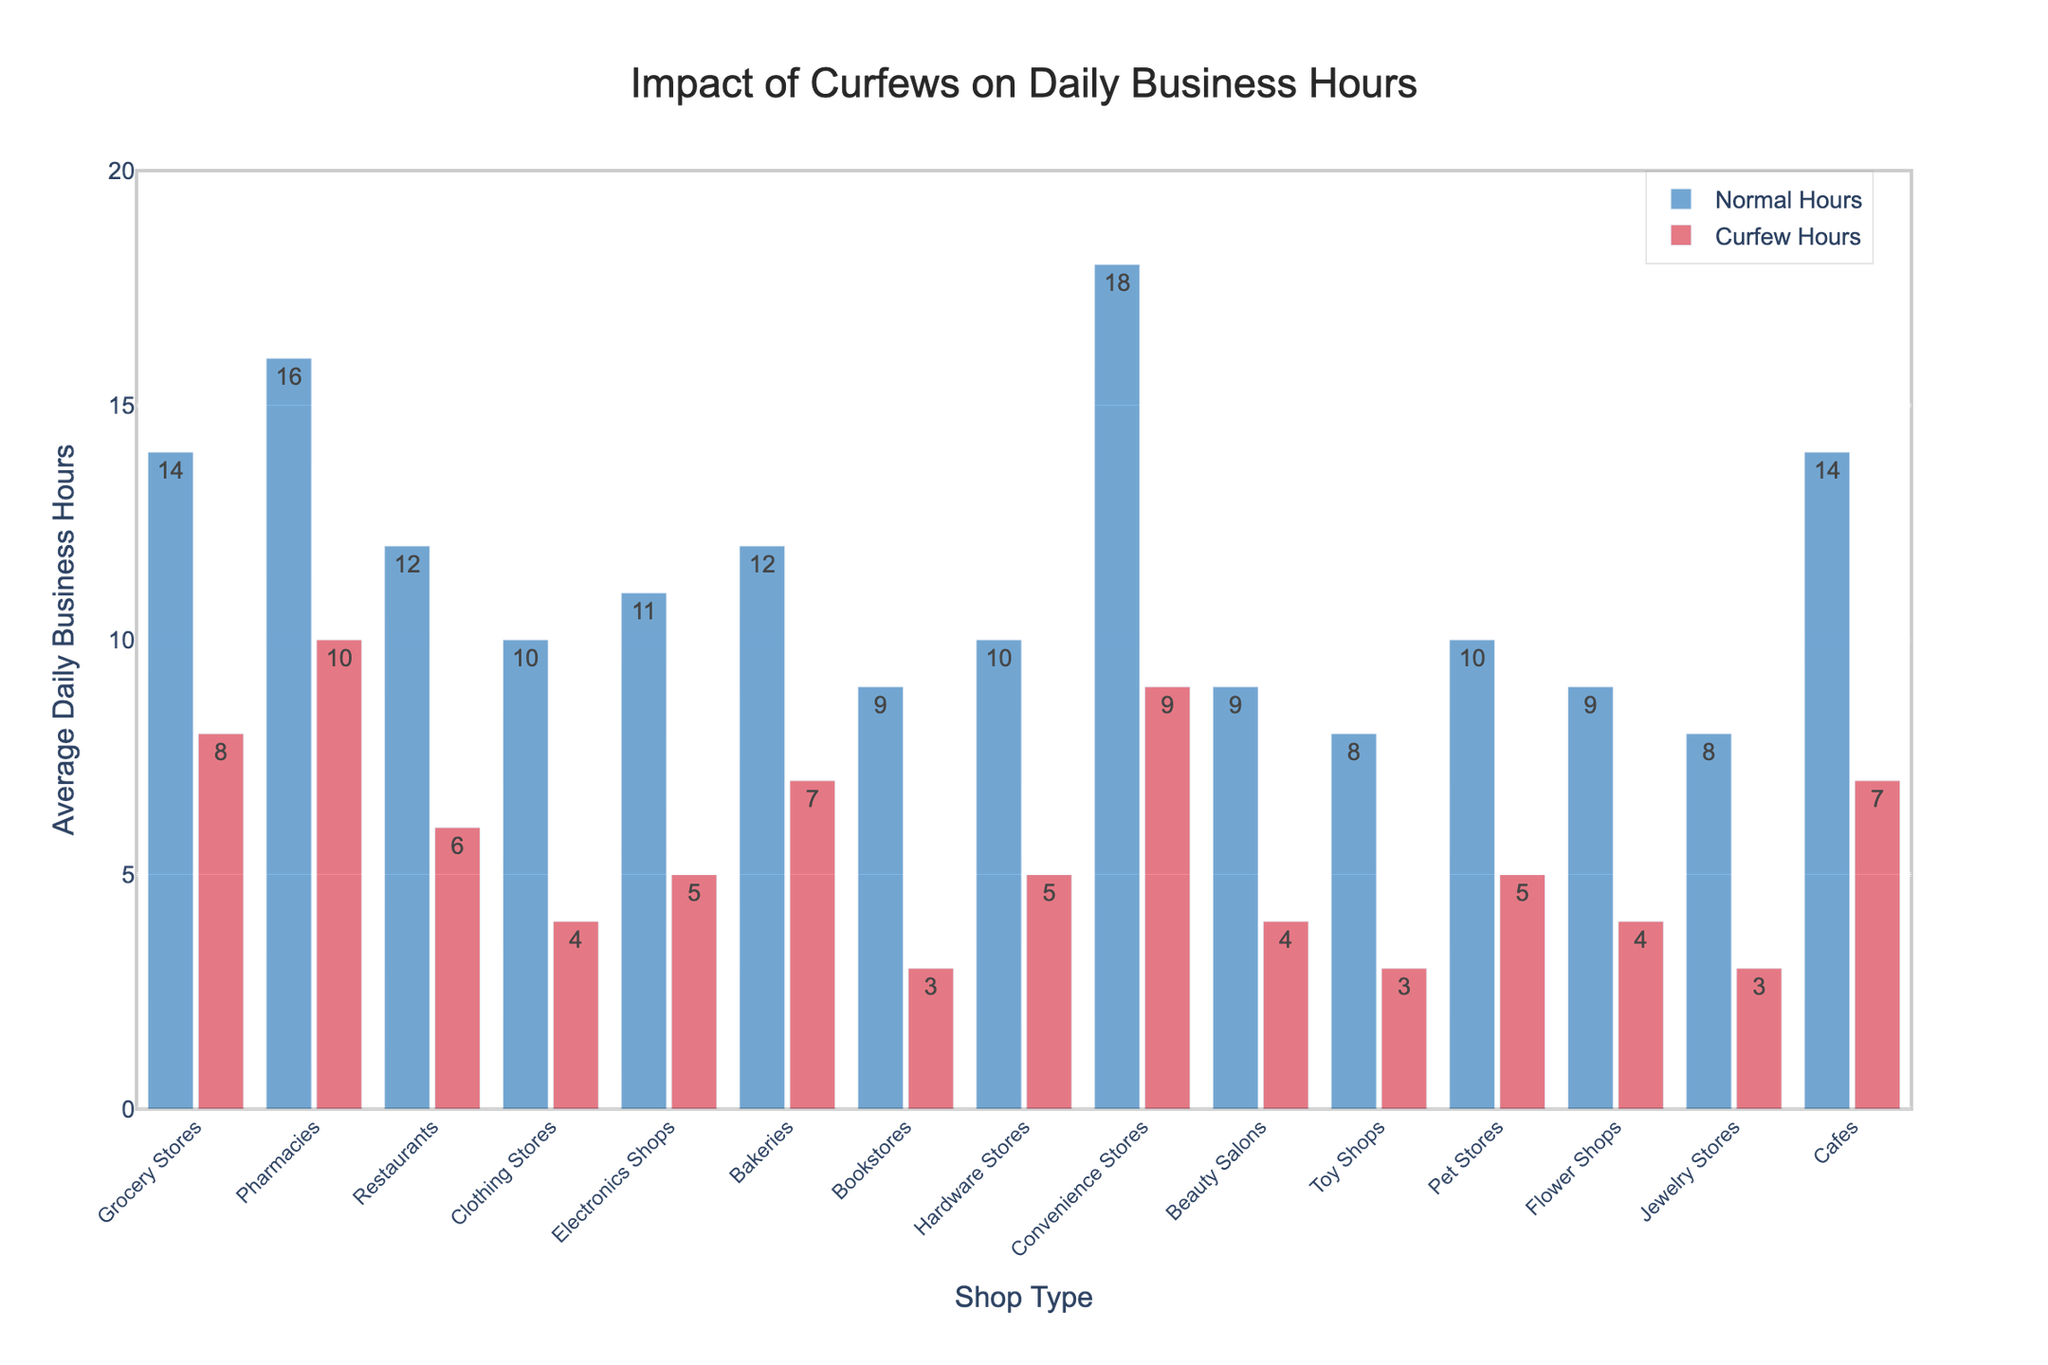Which shop type has the largest decrease in daily business hours due to curfews? Compare the difference between normal and curfew hours for each shop type. The largest decrease is for Clothing Stores, which have a drop from 10 hours to 4 hours, a decrease of 6 hours.
Answer: Clothing Stores Which shop type remains open the longest during curfews? Examine the "Curfew Hours" for each shop type. Convenience Stores remain open the longest with 9 hours per day during curfews.
Answer: Convenience Stores What is the average daily business hours reduction for Grocery Stores, Pharmacies, and Restaurants during curfews? Calculate the individual reductions: Grocery Stores (14 - 8 = 6), Pharmacies (16 - 10 = 6), Restaurants (12 - 6 = 6). The average reduction is (6 + 6 + 6) / 3 = 6 hours.
Answer: 6 hours Which has more reduction in daily business hours during curfews: Cafes or Pharmacies? Compare the difference in hours: Cafes (14 - 7 = 7), Pharmacies (16 - 10 = 6). Cafes have a greater reduction of 7 hours compared to Pharmacies' 6 hours.
Answer: Cafes How many shop types have a curfew business hours reduction of 5 hours or more? Count the shop types where the difference between normal and curfew hours is at least 5: Grocery Stores, Pharmacies, Restaurants, Clothing Stores, Electronics Shops, Convenience Stores, Cafes. This makes a total of 7 shop types.
Answer: 7 Which shop types have equal reductions in daily business hours during curfews? Identify shop types with the same hours reduction: Pet Stores and Hardware Stores both reduce by 5 hours, Beauty Salons and Flower Shops both reduce by 5 hours, Toy Shops, Bookstores, and Jewelry Stores each reduce by 5 hours.
Answer: Pet Stores, Hardware Stores; Beauty Salons, Flower Shops; Toy Shops, Bookstores, Jewelry Stores Out of all shop types, for which shop type are the curfew business hours exactly half of their normal business hours? Compare each shop type: Convenience Stores are normally open for 18 hours and during curfew for 9 hours, exactly half.
Answer: Convenience Stores 